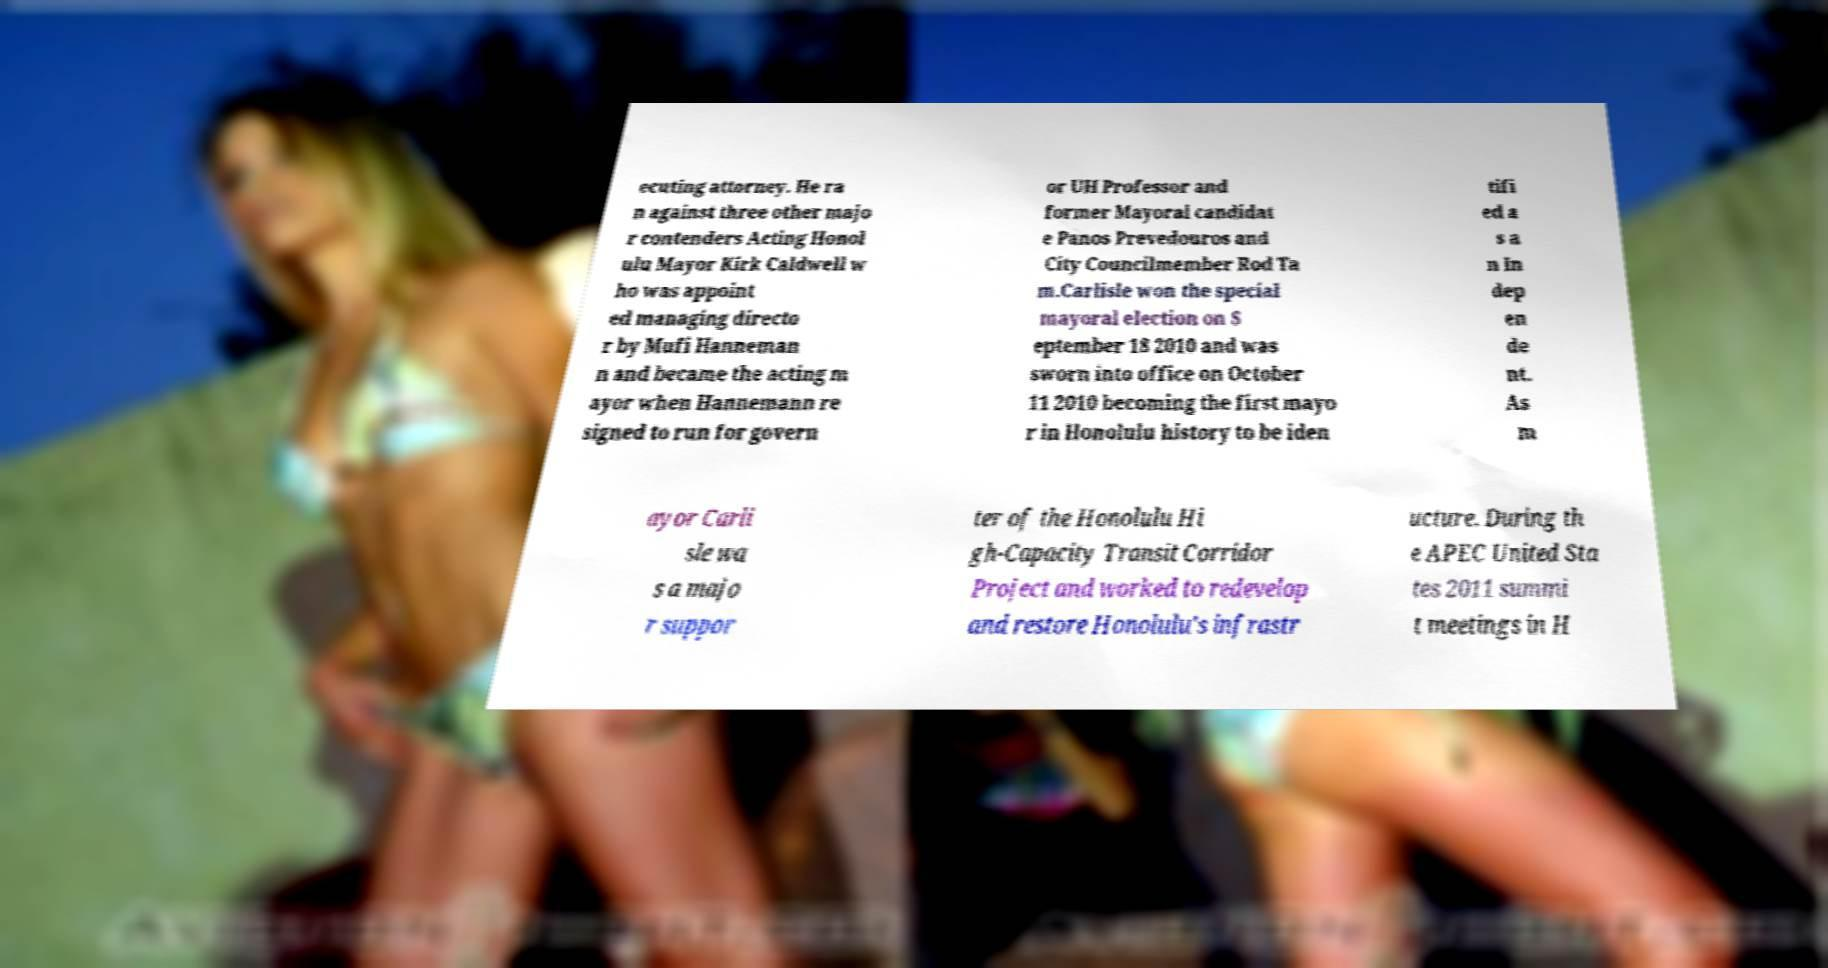For documentation purposes, I need the text within this image transcribed. Could you provide that? ecuting attorney. He ra n against three other majo r contenders Acting Honol ulu Mayor Kirk Caldwell w ho was appoint ed managing directo r by Mufi Hanneman n and became the acting m ayor when Hannemann re signed to run for govern or UH Professor and former Mayoral candidat e Panos Prevedouros and City Councilmember Rod Ta m.Carlisle won the special mayoral election on S eptember 18 2010 and was sworn into office on October 11 2010 becoming the first mayo r in Honolulu history to be iden tifi ed a s a n In dep en de nt. As m ayor Carli sle wa s a majo r suppor ter of the Honolulu Hi gh-Capacity Transit Corridor Project and worked to redevelop and restore Honolulu's infrastr ucture. During th e APEC United Sta tes 2011 summi t meetings in H 